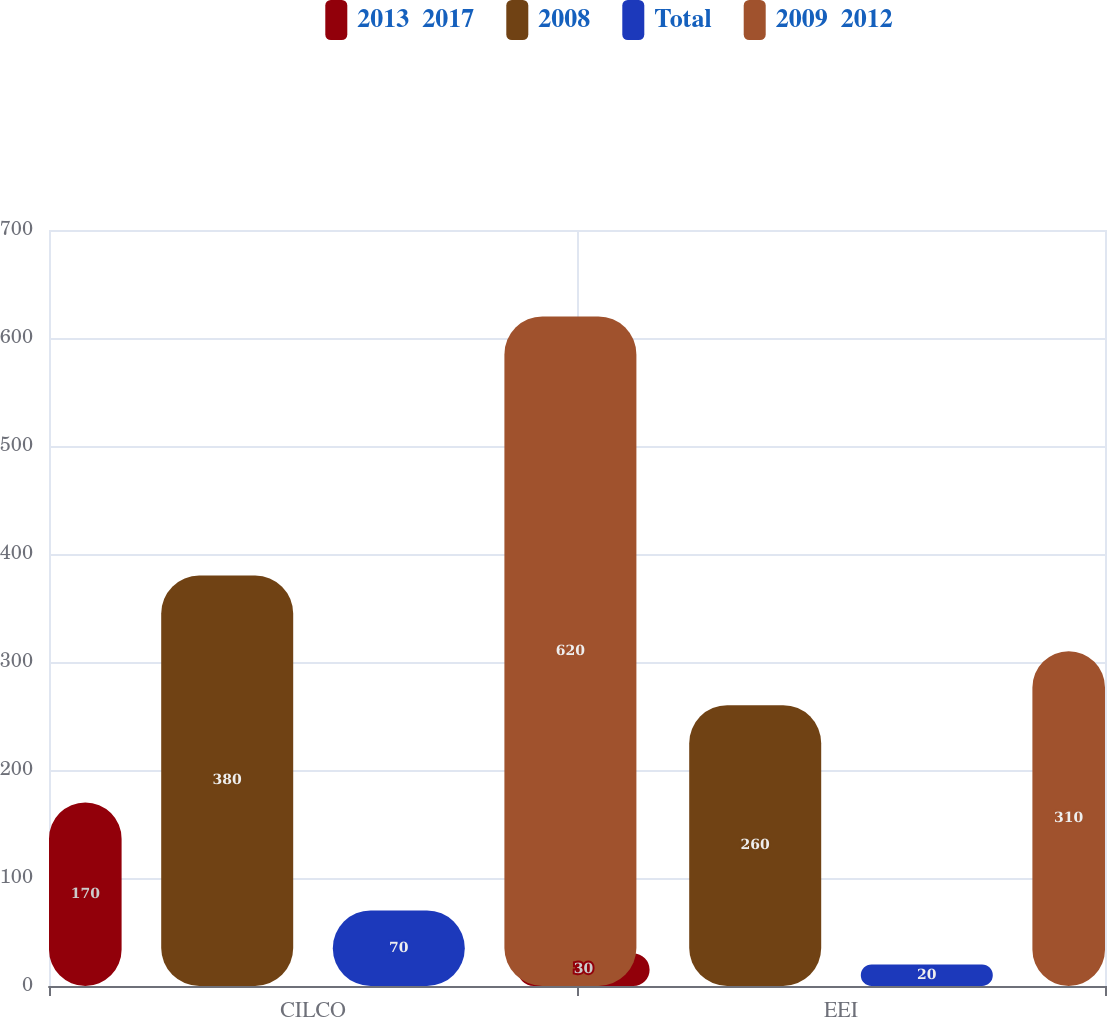Convert chart to OTSL. <chart><loc_0><loc_0><loc_500><loc_500><stacked_bar_chart><ecel><fcel>CILCO<fcel>EEI<nl><fcel>2013  2017<fcel>170<fcel>30<nl><fcel>2008<fcel>380<fcel>260<nl><fcel>Total<fcel>70<fcel>20<nl><fcel>2009  2012<fcel>620<fcel>310<nl></chart> 